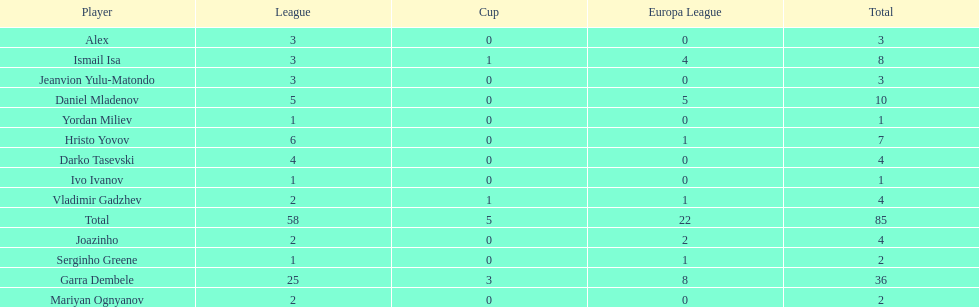Which players have at least 4 in the europa league? Garra Dembele, Daniel Mladenov, Ismail Isa. 